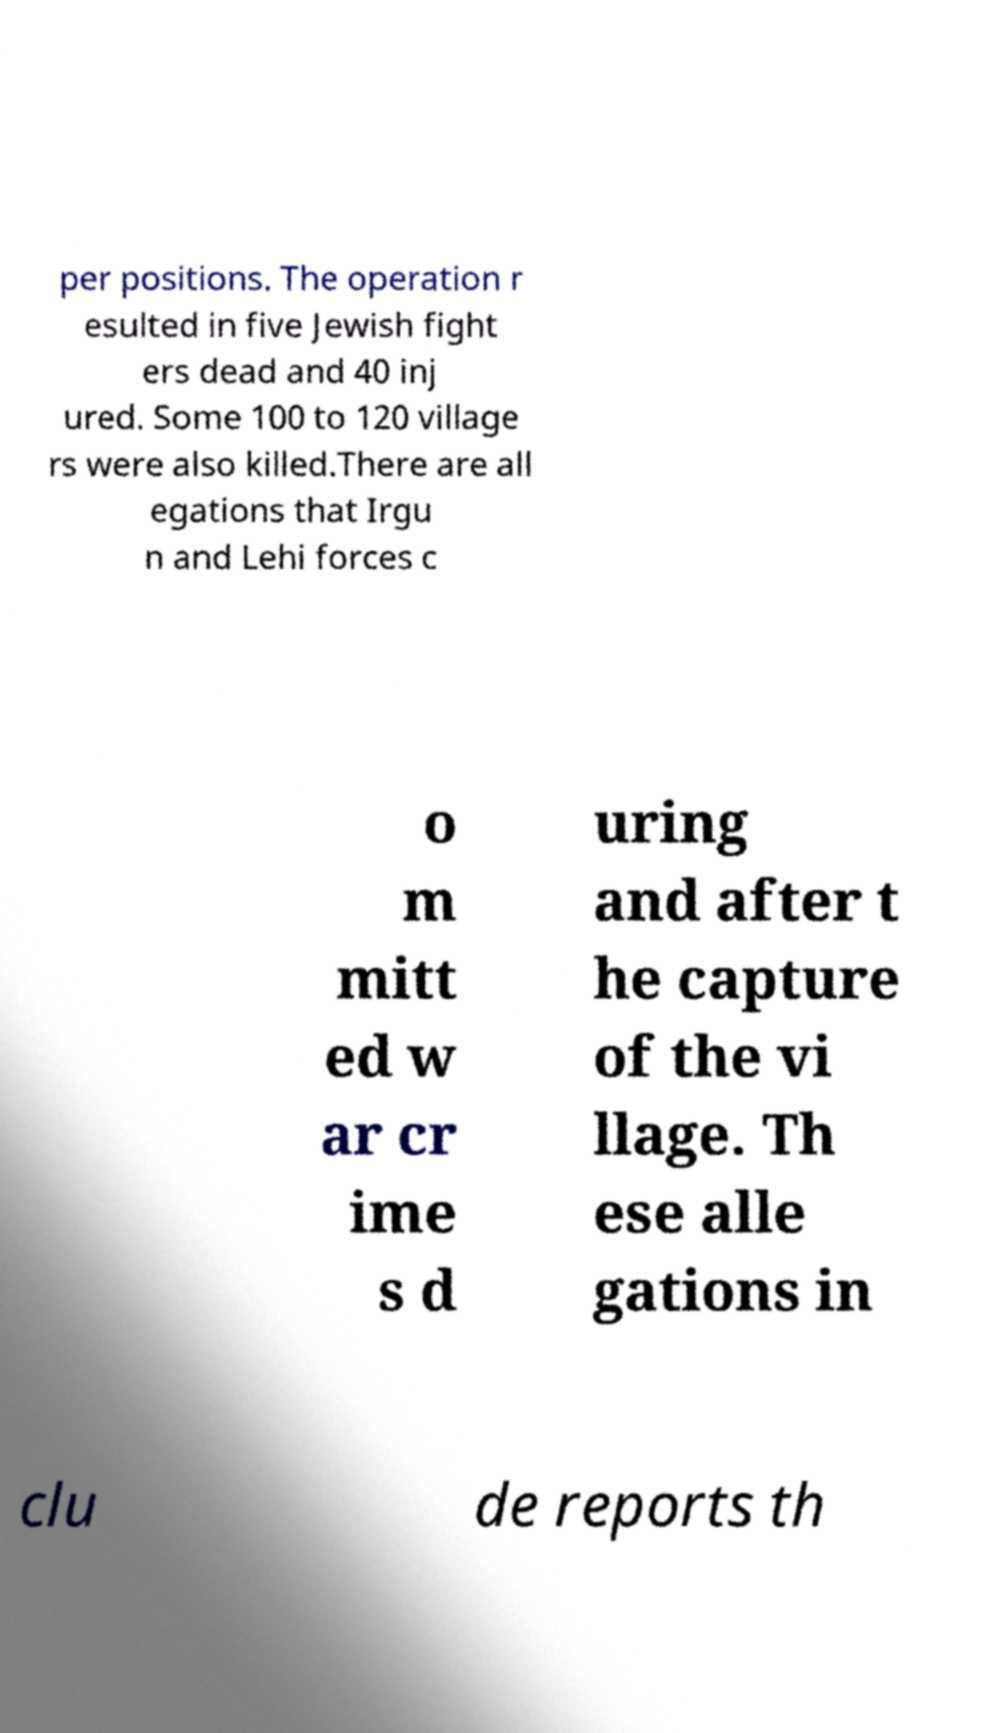Could you extract and type out the text from this image? per positions. The operation r esulted in five Jewish fight ers dead and 40 inj ured. Some 100 to 120 village rs were also killed.There are all egations that Irgu n and Lehi forces c o m mitt ed w ar cr ime s d uring and after t he capture of the vi llage. Th ese alle gations in clu de reports th 